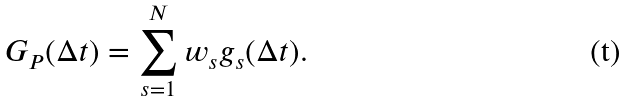Convert formula to latex. <formula><loc_0><loc_0><loc_500><loc_500>G _ { P } ( \Delta t ) = \sum _ { s = 1 } ^ { N } w _ { s } g _ { s } ( \Delta t ) .</formula> 